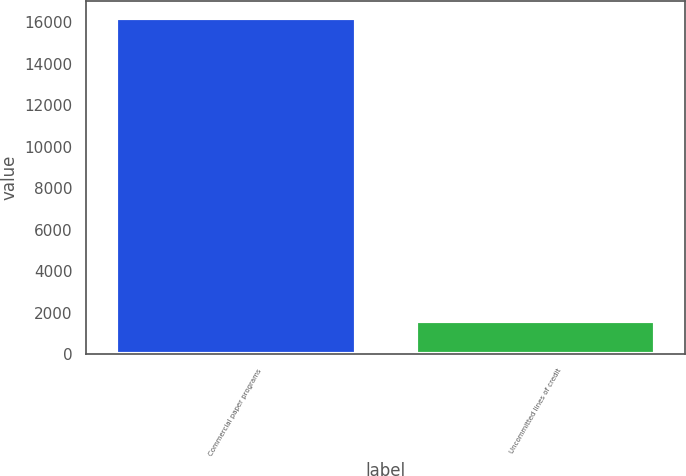Convert chart to OTSL. <chart><loc_0><loc_0><loc_500><loc_500><bar_chart><fcel>Commercial paper programs<fcel>Uncommitted lines of credit<nl><fcel>16202<fcel>1587<nl></chart> 